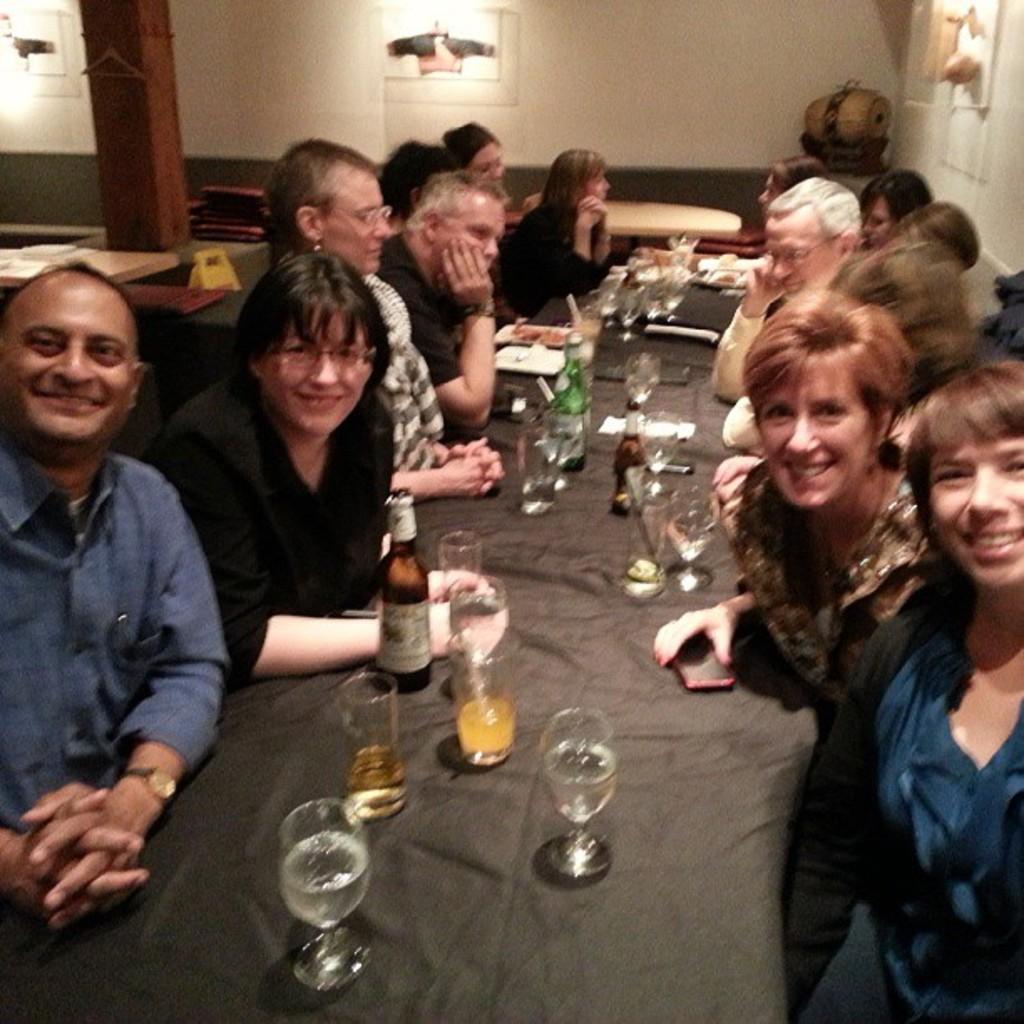Can you describe this image briefly? In this image we can see a group of persons sitting. In front of the persons we can see the drinks on the table. Behind the persons we can see the wall, tables and a pillar. On the wall we can see few objects. 